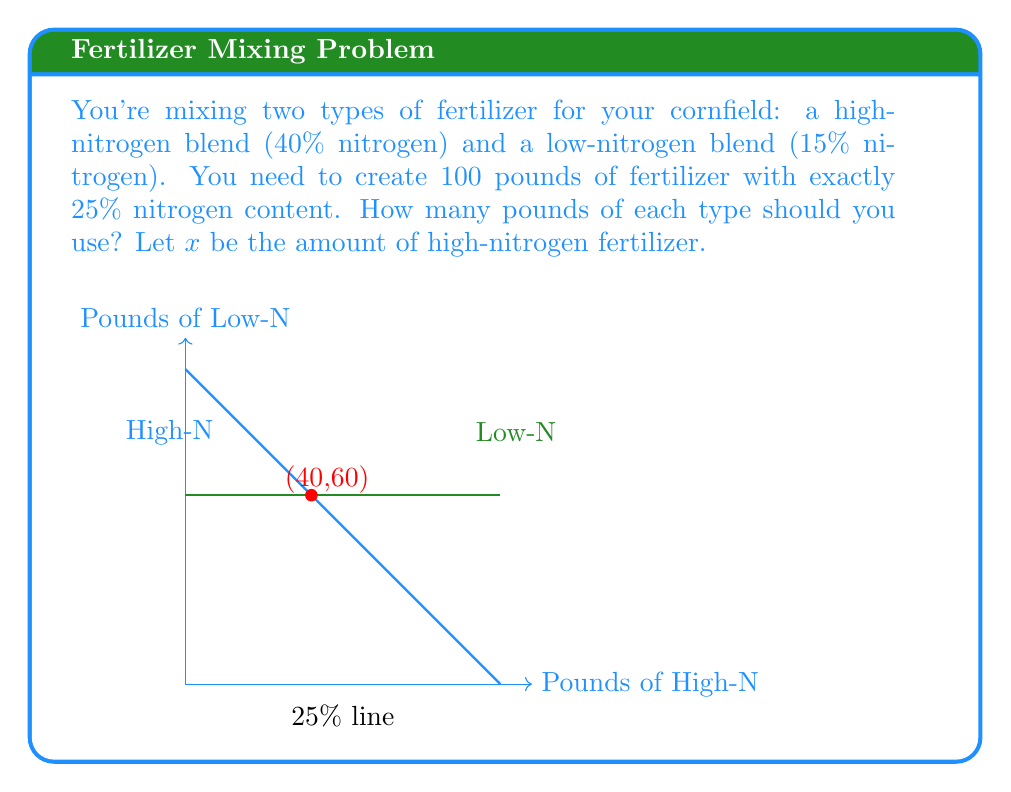Give your solution to this math problem. Let's approach this step-by-step:

1) Let $x$ be the amount of high-nitrogen fertilizer, and $(100-x)$ be the amount of low-nitrogen fertilizer.

2) We can set up an equation based on the nitrogen content:

   $$0.40x + 0.15(100-x) = 0.25(100)$$

3) Simplify the right side:

   $$0.40x + 0.15(100-x) = 25$$

4) Distribute on the left side:

   $$0.40x + 15 - 0.15x = 25$$

5) Combine like terms:

   $$0.25x + 15 = 25$$

6) Subtract 15 from both sides:

   $$0.25x = 10$$

7) Divide both sides by 0.25:

   $$x = 40$$

8) Therefore, we need 40 pounds of high-nitrogen fertilizer.

9) The amount of low-nitrogen fertilizer is $100 - 40 = 60$ pounds.

10) We can verify: $0.40(40) + 0.15(60) = 16 + 9 = 25$ pounds of nitrogen, which is 25% of 100 pounds.
Answer: 40 lbs high-nitrogen, 60 lbs low-nitrogen 